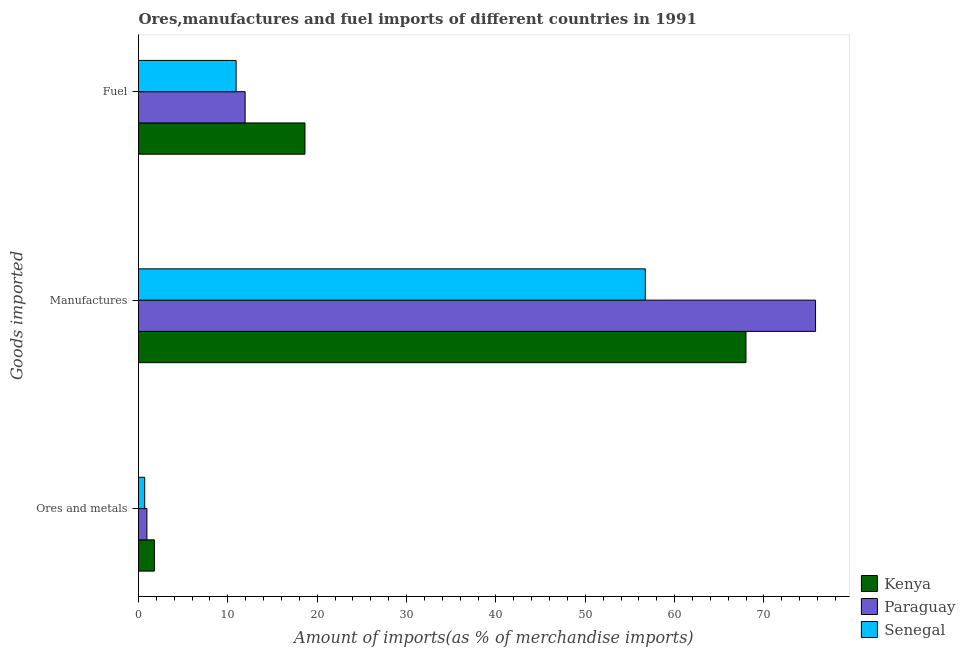Are the number of bars per tick equal to the number of legend labels?
Give a very brief answer. Yes. How many bars are there on the 1st tick from the bottom?
Offer a terse response. 3. What is the label of the 3rd group of bars from the top?
Give a very brief answer. Ores and metals. What is the percentage of manufactures imports in Paraguay?
Give a very brief answer. 75.77. Across all countries, what is the maximum percentage of ores and metals imports?
Provide a succinct answer. 1.78. Across all countries, what is the minimum percentage of ores and metals imports?
Your answer should be very brief. 0.69. In which country was the percentage of ores and metals imports maximum?
Keep it short and to the point. Kenya. In which country was the percentage of manufactures imports minimum?
Keep it short and to the point. Senegal. What is the total percentage of fuel imports in the graph?
Ensure brevity in your answer.  41.49. What is the difference between the percentage of ores and metals imports in Senegal and that in Paraguay?
Offer a very short reply. -0.25. What is the difference between the percentage of fuel imports in Kenya and the percentage of manufactures imports in Senegal?
Provide a short and direct response. -38.09. What is the average percentage of fuel imports per country?
Give a very brief answer. 13.83. What is the difference between the percentage of manufactures imports and percentage of fuel imports in Kenya?
Offer a very short reply. 49.36. In how many countries, is the percentage of fuel imports greater than 22 %?
Your answer should be very brief. 0. What is the ratio of the percentage of manufactures imports in Paraguay to that in Senegal?
Provide a short and direct response. 1.34. Is the percentage of ores and metals imports in Kenya less than that in Paraguay?
Give a very brief answer. No. Is the difference between the percentage of manufactures imports in Kenya and Senegal greater than the difference between the percentage of ores and metals imports in Kenya and Senegal?
Give a very brief answer. Yes. What is the difference between the highest and the second highest percentage of manufactures imports?
Keep it short and to the point. 7.78. What is the difference between the highest and the lowest percentage of fuel imports?
Your answer should be compact. 7.71. In how many countries, is the percentage of fuel imports greater than the average percentage of fuel imports taken over all countries?
Your answer should be compact. 1. Is the sum of the percentage of manufactures imports in Paraguay and Kenya greater than the maximum percentage of fuel imports across all countries?
Ensure brevity in your answer.  Yes. What does the 1st bar from the top in Fuel represents?
Provide a short and direct response. Senegal. What does the 3rd bar from the bottom in Manufactures represents?
Offer a terse response. Senegal. Is it the case that in every country, the sum of the percentage of ores and metals imports and percentage of manufactures imports is greater than the percentage of fuel imports?
Give a very brief answer. Yes. How many legend labels are there?
Keep it short and to the point. 3. What is the title of the graph?
Provide a short and direct response. Ores,manufactures and fuel imports of different countries in 1991. Does "Georgia" appear as one of the legend labels in the graph?
Give a very brief answer. No. What is the label or title of the X-axis?
Your response must be concise. Amount of imports(as % of merchandise imports). What is the label or title of the Y-axis?
Your answer should be compact. Goods imported. What is the Amount of imports(as % of merchandise imports) of Kenya in Ores and metals?
Offer a terse response. 1.78. What is the Amount of imports(as % of merchandise imports) of Paraguay in Ores and metals?
Offer a very short reply. 0.94. What is the Amount of imports(as % of merchandise imports) of Senegal in Ores and metals?
Your response must be concise. 0.69. What is the Amount of imports(as % of merchandise imports) in Kenya in Manufactures?
Make the answer very short. 67.99. What is the Amount of imports(as % of merchandise imports) of Paraguay in Manufactures?
Offer a very short reply. 75.77. What is the Amount of imports(as % of merchandise imports) in Senegal in Manufactures?
Offer a very short reply. 56.72. What is the Amount of imports(as % of merchandise imports) of Kenya in Fuel?
Your answer should be very brief. 18.63. What is the Amount of imports(as % of merchandise imports) of Paraguay in Fuel?
Your answer should be very brief. 11.93. What is the Amount of imports(as % of merchandise imports) in Senegal in Fuel?
Ensure brevity in your answer.  10.92. Across all Goods imported, what is the maximum Amount of imports(as % of merchandise imports) of Kenya?
Ensure brevity in your answer.  67.99. Across all Goods imported, what is the maximum Amount of imports(as % of merchandise imports) of Paraguay?
Give a very brief answer. 75.77. Across all Goods imported, what is the maximum Amount of imports(as % of merchandise imports) in Senegal?
Provide a short and direct response. 56.72. Across all Goods imported, what is the minimum Amount of imports(as % of merchandise imports) in Kenya?
Offer a very short reply. 1.78. Across all Goods imported, what is the minimum Amount of imports(as % of merchandise imports) of Paraguay?
Your answer should be compact. 0.94. Across all Goods imported, what is the minimum Amount of imports(as % of merchandise imports) in Senegal?
Your answer should be very brief. 0.69. What is the total Amount of imports(as % of merchandise imports) in Kenya in the graph?
Make the answer very short. 88.39. What is the total Amount of imports(as % of merchandise imports) of Paraguay in the graph?
Provide a succinct answer. 88.64. What is the total Amount of imports(as % of merchandise imports) of Senegal in the graph?
Make the answer very short. 68.33. What is the difference between the Amount of imports(as % of merchandise imports) in Kenya in Ores and metals and that in Manufactures?
Provide a short and direct response. -66.21. What is the difference between the Amount of imports(as % of merchandise imports) of Paraguay in Ores and metals and that in Manufactures?
Offer a terse response. -74.83. What is the difference between the Amount of imports(as % of merchandise imports) in Senegal in Ores and metals and that in Manufactures?
Ensure brevity in your answer.  -56.02. What is the difference between the Amount of imports(as % of merchandise imports) of Kenya in Ores and metals and that in Fuel?
Provide a succinct answer. -16.85. What is the difference between the Amount of imports(as % of merchandise imports) in Paraguay in Ores and metals and that in Fuel?
Your response must be concise. -10.99. What is the difference between the Amount of imports(as % of merchandise imports) in Senegal in Ores and metals and that in Fuel?
Ensure brevity in your answer.  -10.23. What is the difference between the Amount of imports(as % of merchandise imports) of Kenya in Manufactures and that in Fuel?
Your answer should be compact. 49.36. What is the difference between the Amount of imports(as % of merchandise imports) of Paraguay in Manufactures and that in Fuel?
Ensure brevity in your answer.  63.84. What is the difference between the Amount of imports(as % of merchandise imports) of Senegal in Manufactures and that in Fuel?
Your response must be concise. 45.79. What is the difference between the Amount of imports(as % of merchandise imports) in Kenya in Ores and metals and the Amount of imports(as % of merchandise imports) in Paraguay in Manufactures?
Ensure brevity in your answer.  -74. What is the difference between the Amount of imports(as % of merchandise imports) in Kenya in Ores and metals and the Amount of imports(as % of merchandise imports) in Senegal in Manufactures?
Provide a succinct answer. -54.94. What is the difference between the Amount of imports(as % of merchandise imports) in Paraguay in Ores and metals and the Amount of imports(as % of merchandise imports) in Senegal in Manufactures?
Offer a terse response. -55.78. What is the difference between the Amount of imports(as % of merchandise imports) of Kenya in Ores and metals and the Amount of imports(as % of merchandise imports) of Paraguay in Fuel?
Offer a terse response. -10.16. What is the difference between the Amount of imports(as % of merchandise imports) in Kenya in Ores and metals and the Amount of imports(as % of merchandise imports) in Senegal in Fuel?
Ensure brevity in your answer.  -9.15. What is the difference between the Amount of imports(as % of merchandise imports) in Paraguay in Ores and metals and the Amount of imports(as % of merchandise imports) in Senegal in Fuel?
Give a very brief answer. -9.98. What is the difference between the Amount of imports(as % of merchandise imports) in Kenya in Manufactures and the Amount of imports(as % of merchandise imports) in Paraguay in Fuel?
Give a very brief answer. 56.06. What is the difference between the Amount of imports(as % of merchandise imports) in Kenya in Manufactures and the Amount of imports(as % of merchandise imports) in Senegal in Fuel?
Your answer should be compact. 57.06. What is the difference between the Amount of imports(as % of merchandise imports) in Paraguay in Manufactures and the Amount of imports(as % of merchandise imports) in Senegal in Fuel?
Provide a succinct answer. 64.85. What is the average Amount of imports(as % of merchandise imports) of Kenya per Goods imported?
Offer a very short reply. 29.46. What is the average Amount of imports(as % of merchandise imports) in Paraguay per Goods imported?
Your response must be concise. 29.55. What is the average Amount of imports(as % of merchandise imports) in Senegal per Goods imported?
Ensure brevity in your answer.  22.78. What is the difference between the Amount of imports(as % of merchandise imports) in Kenya and Amount of imports(as % of merchandise imports) in Paraguay in Ores and metals?
Make the answer very short. 0.84. What is the difference between the Amount of imports(as % of merchandise imports) of Kenya and Amount of imports(as % of merchandise imports) of Senegal in Ores and metals?
Provide a succinct answer. 1.08. What is the difference between the Amount of imports(as % of merchandise imports) of Paraguay and Amount of imports(as % of merchandise imports) of Senegal in Ores and metals?
Keep it short and to the point. 0.25. What is the difference between the Amount of imports(as % of merchandise imports) in Kenya and Amount of imports(as % of merchandise imports) in Paraguay in Manufactures?
Provide a succinct answer. -7.78. What is the difference between the Amount of imports(as % of merchandise imports) in Kenya and Amount of imports(as % of merchandise imports) in Senegal in Manufactures?
Your answer should be very brief. 11.27. What is the difference between the Amount of imports(as % of merchandise imports) in Paraguay and Amount of imports(as % of merchandise imports) in Senegal in Manufactures?
Provide a short and direct response. 19.05. What is the difference between the Amount of imports(as % of merchandise imports) in Kenya and Amount of imports(as % of merchandise imports) in Paraguay in Fuel?
Offer a very short reply. 6.7. What is the difference between the Amount of imports(as % of merchandise imports) in Kenya and Amount of imports(as % of merchandise imports) in Senegal in Fuel?
Offer a very short reply. 7.71. What is the difference between the Amount of imports(as % of merchandise imports) in Paraguay and Amount of imports(as % of merchandise imports) in Senegal in Fuel?
Your answer should be very brief. 1.01. What is the ratio of the Amount of imports(as % of merchandise imports) of Kenya in Ores and metals to that in Manufactures?
Offer a terse response. 0.03. What is the ratio of the Amount of imports(as % of merchandise imports) of Paraguay in Ores and metals to that in Manufactures?
Give a very brief answer. 0.01. What is the ratio of the Amount of imports(as % of merchandise imports) in Senegal in Ores and metals to that in Manufactures?
Provide a succinct answer. 0.01. What is the ratio of the Amount of imports(as % of merchandise imports) in Kenya in Ores and metals to that in Fuel?
Your answer should be very brief. 0.1. What is the ratio of the Amount of imports(as % of merchandise imports) in Paraguay in Ores and metals to that in Fuel?
Make the answer very short. 0.08. What is the ratio of the Amount of imports(as % of merchandise imports) of Senegal in Ores and metals to that in Fuel?
Keep it short and to the point. 0.06. What is the ratio of the Amount of imports(as % of merchandise imports) of Kenya in Manufactures to that in Fuel?
Your answer should be compact. 3.65. What is the ratio of the Amount of imports(as % of merchandise imports) of Paraguay in Manufactures to that in Fuel?
Provide a short and direct response. 6.35. What is the ratio of the Amount of imports(as % of merchandise imports) of Senegal in Manufactures to that in Fuel?
Provide a short and direct response. 5.19. What is the difference between the highest and the second highest Amount of imports(as % of merchandise imports) in Kenya?
Your answer should be very brief. 49.36. What is the difference between the highest and the second highest Amount of imports(as % of merchandise imports) of Paraguay?
Provide a short and direct response. 63.84. What is the difference between the highest and the second highest Amount of imports(as % of merchandise imports) in Senegal?
Offer a terse response. 45.79. What is the difference between the highest and the lowest Amount of imports(as % of merchandise imports) of Kenya?
Offer a very short reply. 66.21. What is the difference between the highest and the lowest Amount of imports(as % of merchandise imports) in Paraguay?
Give a very brief answer. 74.83. What is the difference between the highest and the lowest Amount of imports(as % of merchandise imports) of Senegal?
Keep it short and to the point. 56.02. 